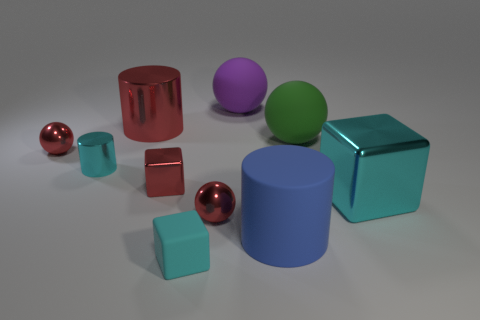Which objects in the image are reflective? The metallic spheres and the cylinder-shaped objects exhibit a reflective surface, which is noticeable by the way they cast lights and shadows. Are there any objects that are the same shape but different sizes? Yes, the cubes and the spheres both have variations in size, with at least two different sizes visible for each shape. 